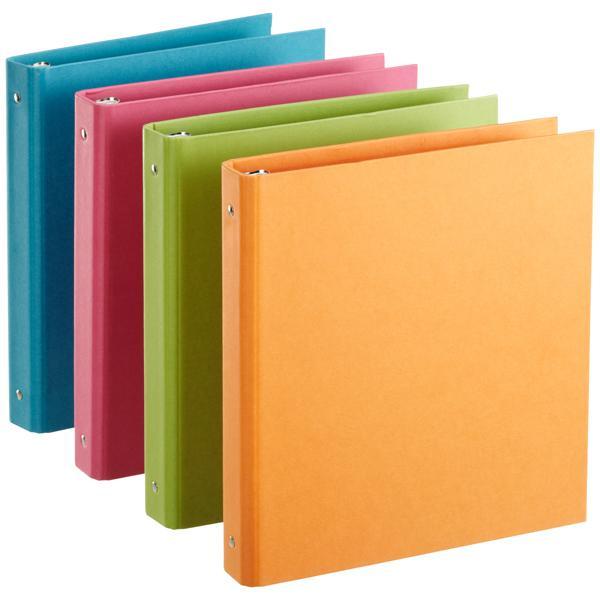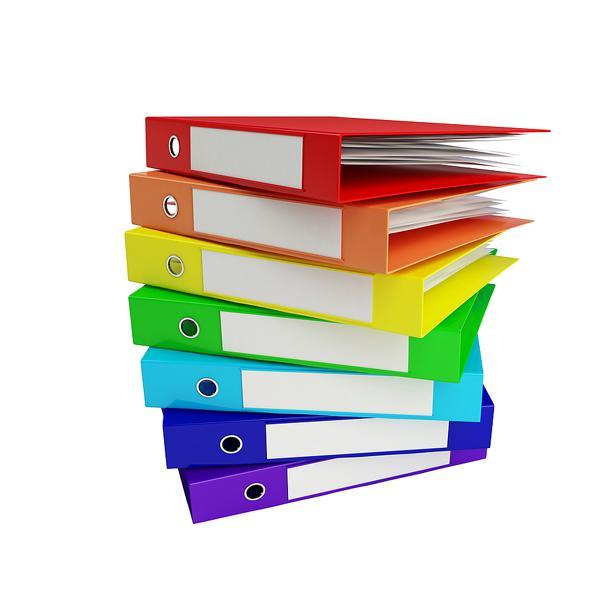The first image is the image on the left, the second image is the image on the right. Examine the images to the left and right. Is the description "One image shows multiple different colored binders without any labels on their ends, and the other image shows different colored binders with end labels." accurate? Answer yes or no. Yes. The first image is the image on the left, the second image is the image on the right. For the images displayed, is the sentence "There is a stack of three binders in the image on the right." factually correct? Answer yes or no. No. 